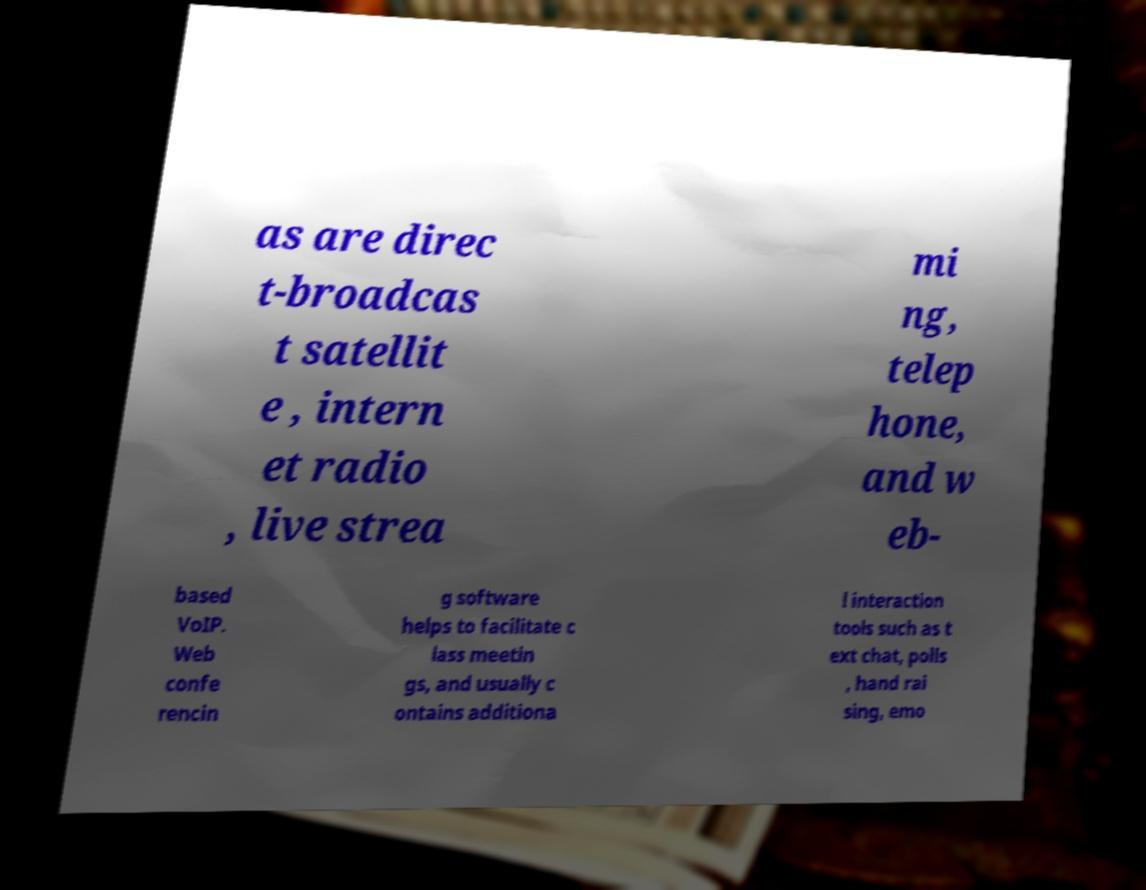What messages or text are displayed in this image? I need them in a readable, typed format. as are direc t-broadcas t satellit e , intern et radio , live strea mi ng, telep hone, and w eb- based VoIP. Web confe rencin g software helps to facilitate c lass meetin gs, and usually c ontains additiona l interaction tools such as t ext chat, polls , hand rai sing, emo 